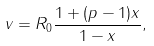<formula> <loc_0><loc_0><loc_500><loc_500>v = R _ { 0 } \frac { 1 + ( p - 1 ) x } { 1 - x } ,</formula> 